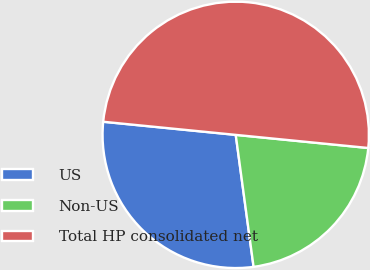<chart> <loc_0><loc_0><loc_500><loc_500><pie_chart><fcel>US<fcel>Non-US<fcel>Total HP consolidated net<nl><fcel>28.71%<fcel>21.29%<fcel>50.0%<nl></chart> 